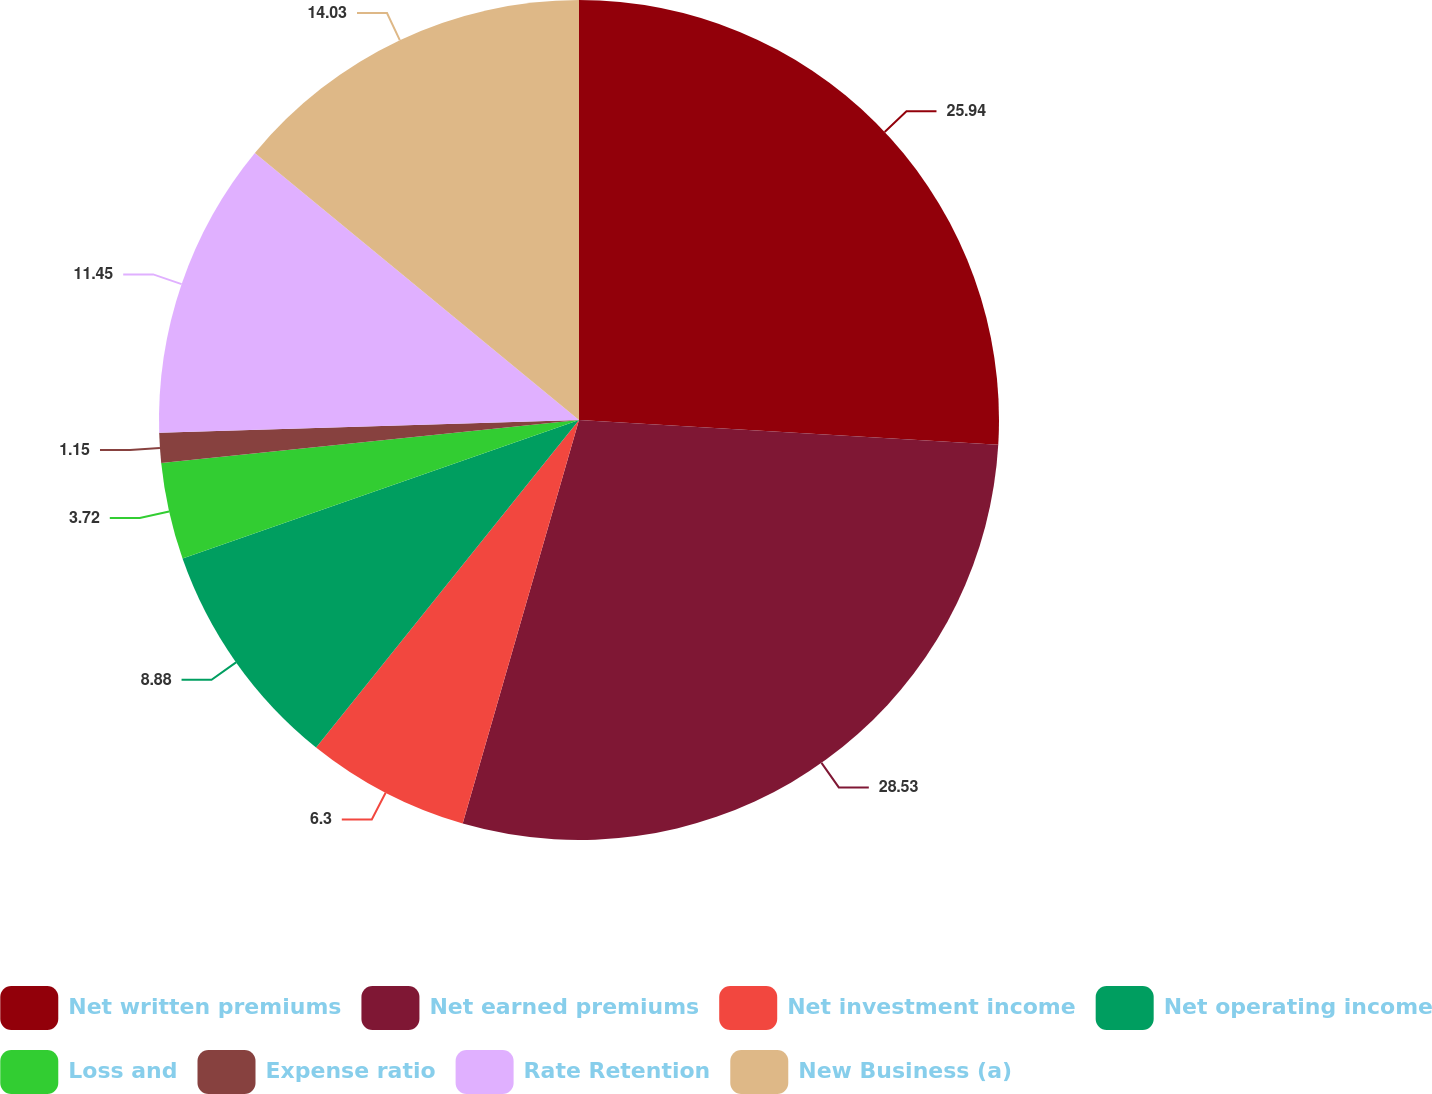<chart> <loc_0><loc_0><loc_500><loc_500><pie_chart><fcel>Net written premiums<fcel>Net earned premiums<fcel>Net investment income<fcel>Net operating income<fcel>Loss and<fcel>Expense ratio<fcel>Rate Retention<fcel>New Business (a)<nl><fcel>25.94%<fcel>28.52%<fcel>6.3%<fcel>8.88%<fcel>3.72%<fcel>1.15%<fcel>11.45%<fcel>14.03%<nl></chart> 